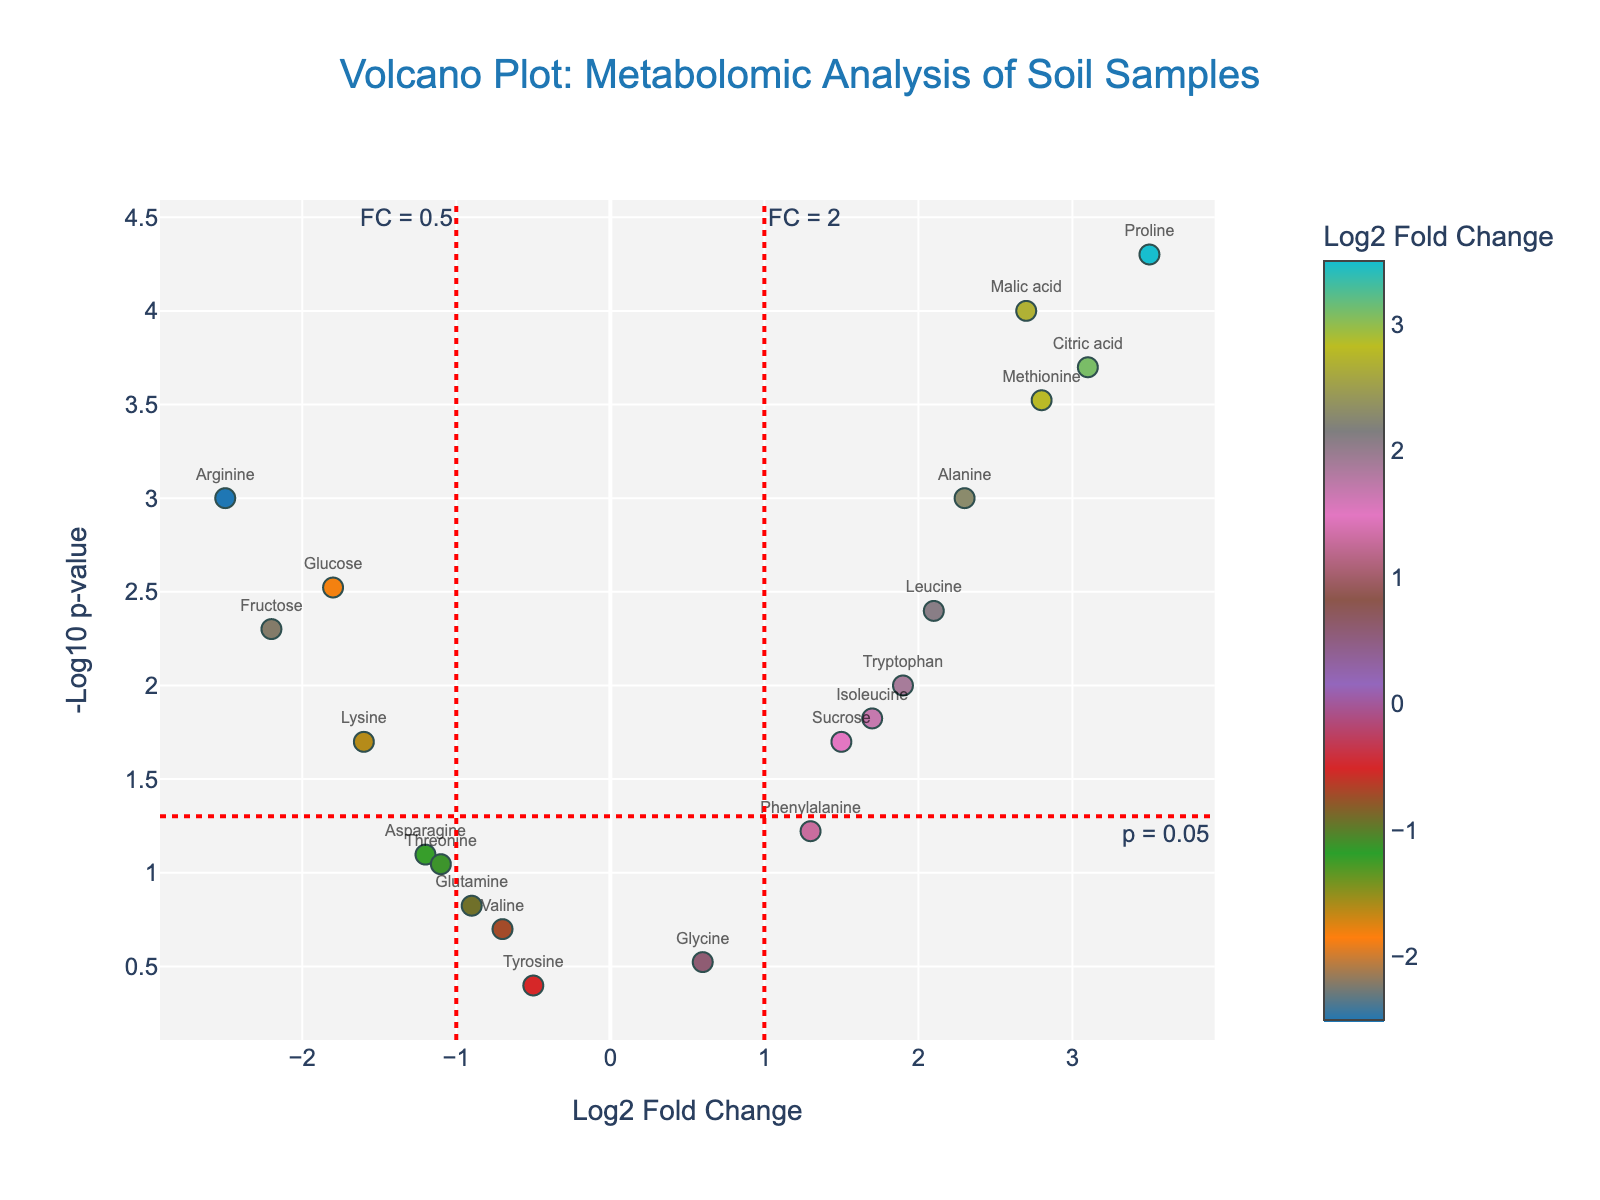Which metabolite has the highest log2 fold change? The metabolite with the highest log2 fold change is the one with the highest value on the x-axis. From the data, Proline has the highest log2 fold change of 3.5.
Answer: Proline Which metabolite has the most significant p-value? The most significant p-value corresponds to the data point with the highest value on the y-axis, as -log10(p-value) increases with decreasing p-value. Malic acid has the highest -log10(p-value), translating to the most significant p-value.
Answer: Malic acid How many metabolites have a log2 fold change greater than 1 and a -log10(p-value) greater than 2? Draw vertical and horizontal lines at 1 on the x-axis and 2 on the y-axis, then count the points in the top-right quadrant. There are 7 metabolites: Alanine, Citric acid, Malic acid, Proline, Tryptophan, Leucine, and Methionine.
Answer: 7 Which metabolite shows a significant decrease in concentration in the soil samples? Significant decreases in concentration are indicated by negative log2 fold changes and high -log10(p-values). Arginine, with a log2 fold change of -2.5 and a p-value of 0.001, shows the most significant decrease.
Answer: Arginine What is the threshold used to determine significance based on p-values? The threshold for significance is typically indicated by a dotted line on the y-axis. In this plot, the red dashed line is at y = 1.3, which corresponds to a p-value of 0.05 (since -log10(0.05) ≈ 1.3).
Answer: 0.05 Which metabolites are considered significantly altered based on both the log2 fold change and p-value thresholds? To determine significant alterations, both a log2 fold change greater than 1 or less than -1 and a p-value less than 0.05 are needed. The metabolites meeting these criteria are Alanine, Citric acid, Proline, Malic acid, Glucose, Fructose, Leucine, Arginine, and Methionine.
Answer: 9 What is the log2 fold change and p-value for Methionine? Locate Methionine on the plot and refer to its detailed info on hover or data set. Methionine has a log2 fold change of 2.8 and a p-value of 0.0003.
Answer: 2.8, 0.0003 Compare the log2 fold changes of Alanine and Glucose. Which one is higher? Alanine's log2 fold change is 2.3, whereas Glucose's is -1.8. Since 2.3 is greater than -1.8, Alanine has a higher log2 fold change.
Answer: Alanine Which metabolites have a log2 fold change close to zero but are not statistically significant? Metabolites with log2 fold changes near 0 but with high p-values (low -log10(p-values)) are not significant. Glycine, Valine, and Tyrosine fall into this category with log2 fold changes of 0.6, -0.7, and -0.5, respectively, and p-values greater than 0.1.
Answer: Glycine, Valine, Tyrosine 